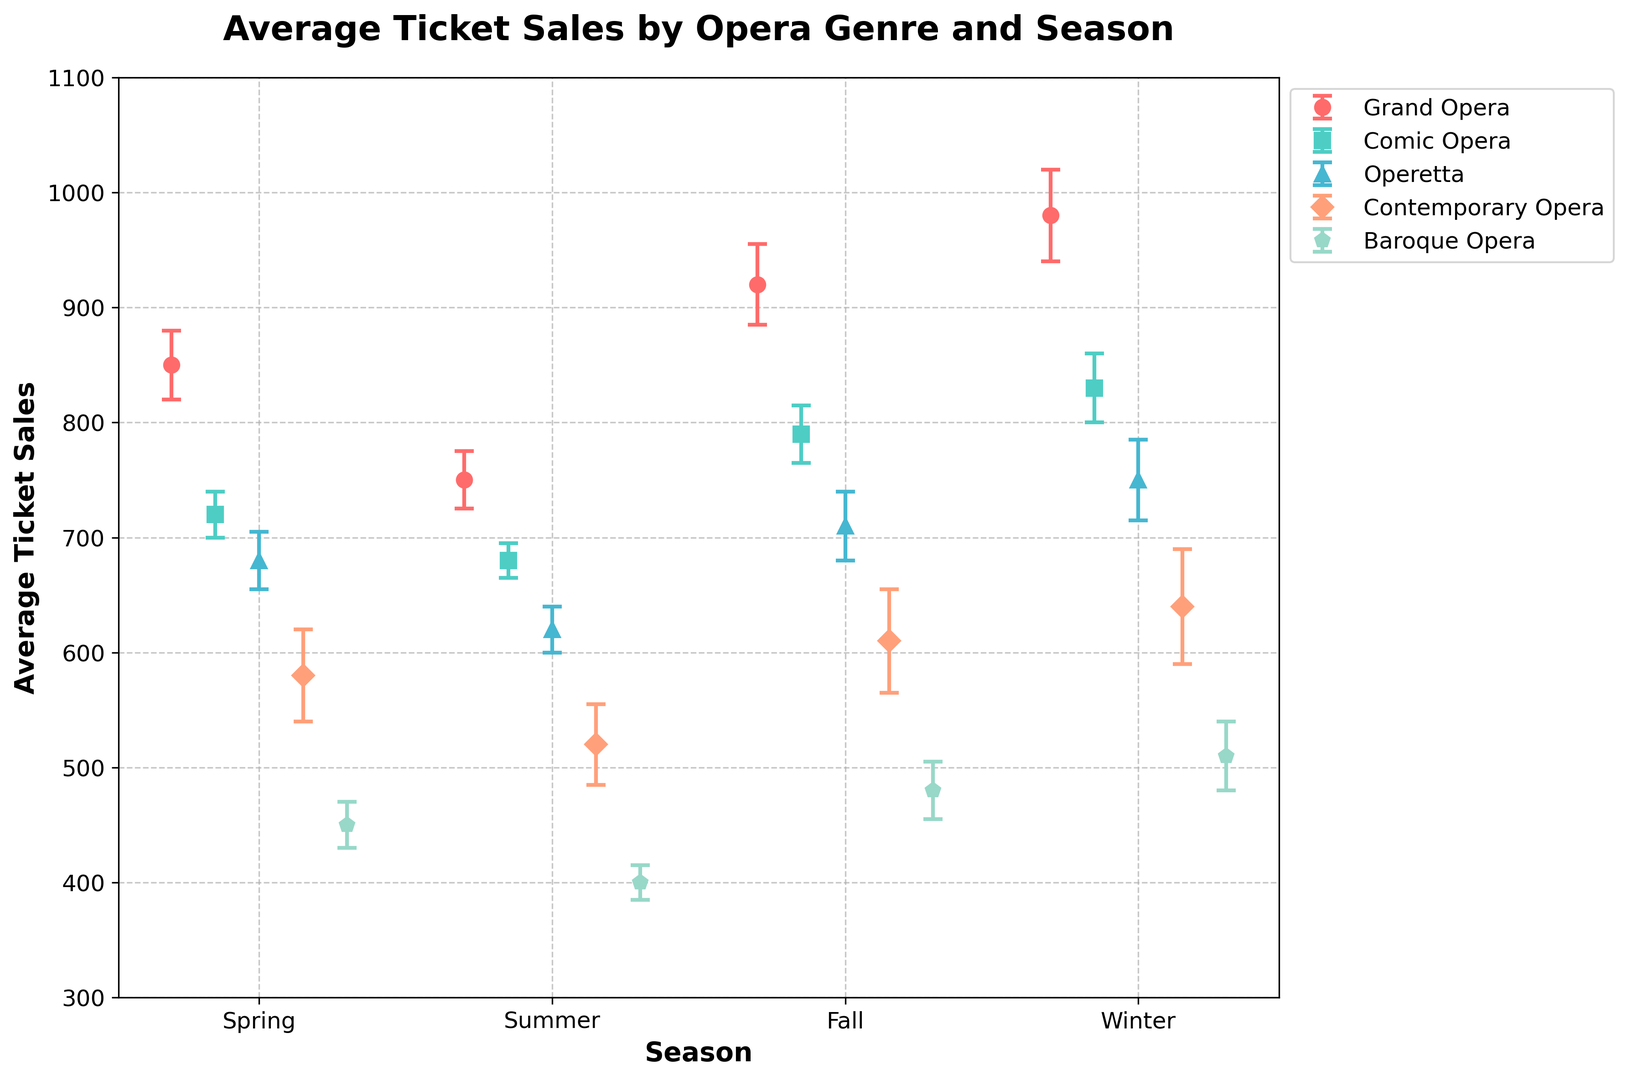Which opera genre has the highest average ticket sales in Winter? First, locate the Winter data points for all genres. Then, compare the average ticket sales values. Grand Opera has the highest value at 980.
Answer: Grand Opera Which season has the lowest average ticket sales for Contemporary Opera? For Contemporary Opera, check the values across all seasons. The lowest is in Summer, with 520 sales.
Answer: Summer Which genre shows the largest difference in average ticket sales between Fall and Winter seasons? Calculate the difference for each genre between Fall and Winter: Grand Opera (980-920=60), Comic Opera (830-790=40), Operetta (750-710=40), Contemporary Opera (640-610=30), Baroque Opera (510-480=30). Grand Opera has the largest difference of 60.
Answer: Grand Opera How does the average ticket sales for Comic Opera in Spring compare to Operetta in Winter? Compare the Spring value for Comic Opera (720) with Winter for Operetta (750). Operetta in Winter is higher.
Answer: Operetta in Winter Is the error margin for Contemporary Opera in Winter larger than in Summer? Compare the error margins: Winter (50) and Summer (35). Winter's error is larger.
Answer: Yes What is the total average ticket sales for Baroque Opera across all seasons? Sum the values across all seasons: 450 (Spring) + 400 (Summer) + 480 (Fall) + 510 (Winter) = 1840.
Answer: 1840 How do the error margins of Grand Opera and Comic Opera in Fall compare visually? Look at the lengths of error bars in Fall for both genres. Grand Opera's error margin (35) is visually longer than Comic Opera's (25).
Answer: Grand Opera's error margin is larger Between Spring and Summer, which season has a greater difference in average ticket sales for Comic Opera? Difference for Comic Opera: Spring (720) - Summer (680) = 40. Difference for Spring and Summer altogether is 40 (Comic Opera).
Answer: Spring and Summer have the same difference What is the average of the highest average ticket sales values for each genre? Identify the highest value of each genre: Grand Opera (980), Comic Opera (830), Operetta (750), Contemporary Opera (640), Baroque Opera (510). Calculate the mean: (980 + 830 + 750 + 640 + 510) / 5 = 742.
Answer: 742 